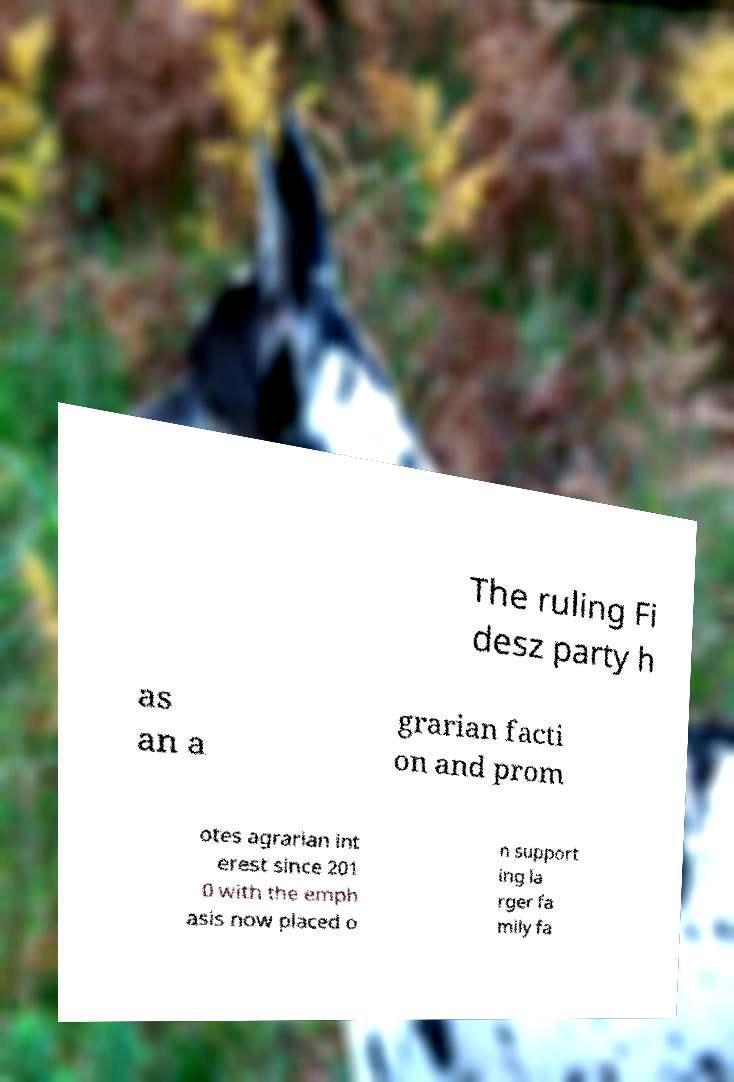There's text embedded in this image that I need extracted. Can you transcribe it verbatim? The ruling Fi desz party h as an a grarian facti on and prom otes agrarian int erest since 201 0 with the emph asis now placed o n support ing la rger fa mily fa 